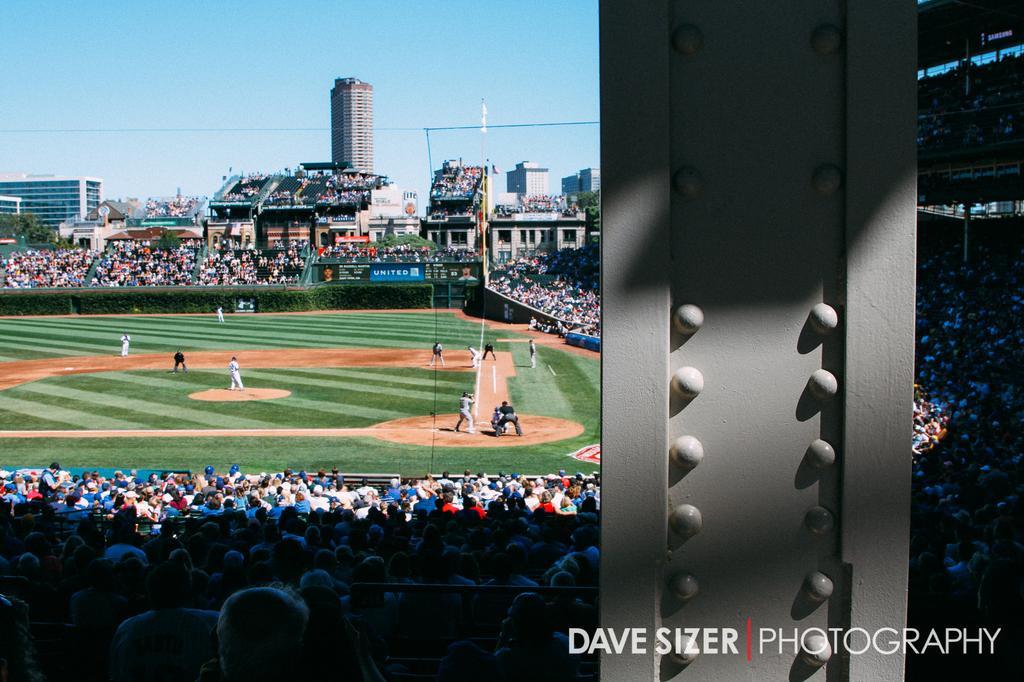In one or two sentences, can you explain what this image depicts? In this image there is a baseball ground players are playing in the ground and audience are sitting on chairs, in the bottom right there is text. 